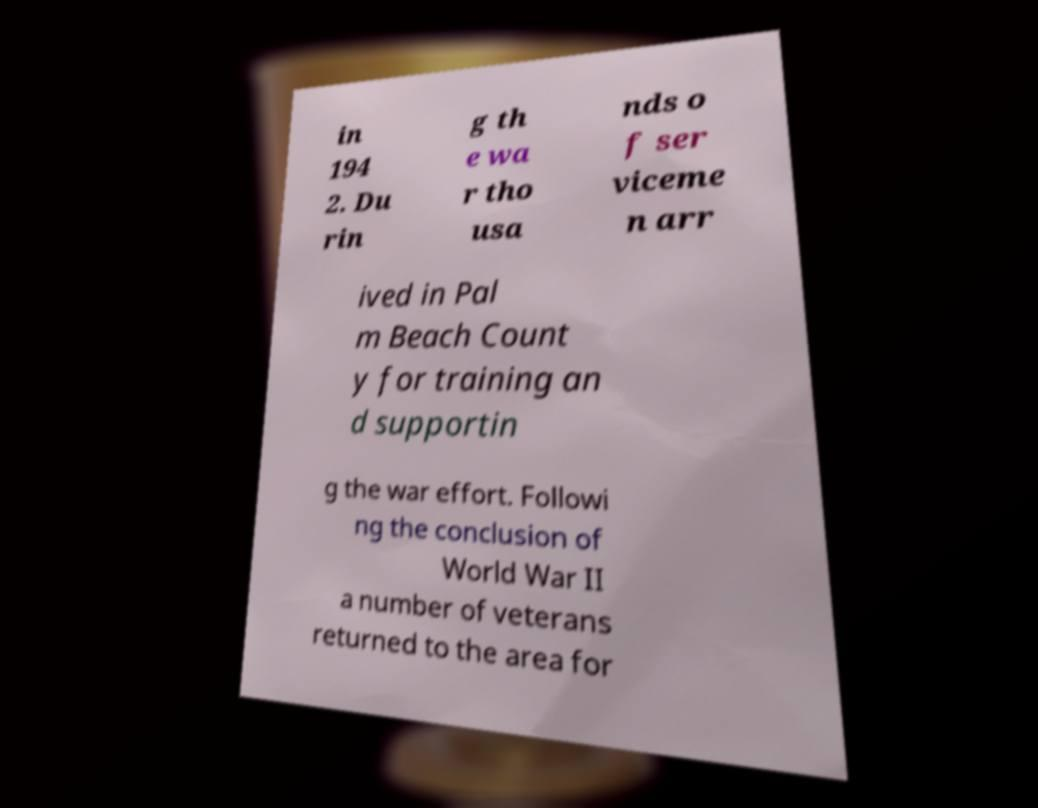Could you assist in decoding the text presented in this image and type it out clearly? in 194 2. Du rin g th e wa r tho usa nds o f ser viceme n arr ived in Pal m Beach Count y for training an d supportin g the war effort. Followi ng the conclusion of World War II a number of veterans returned to the area for 